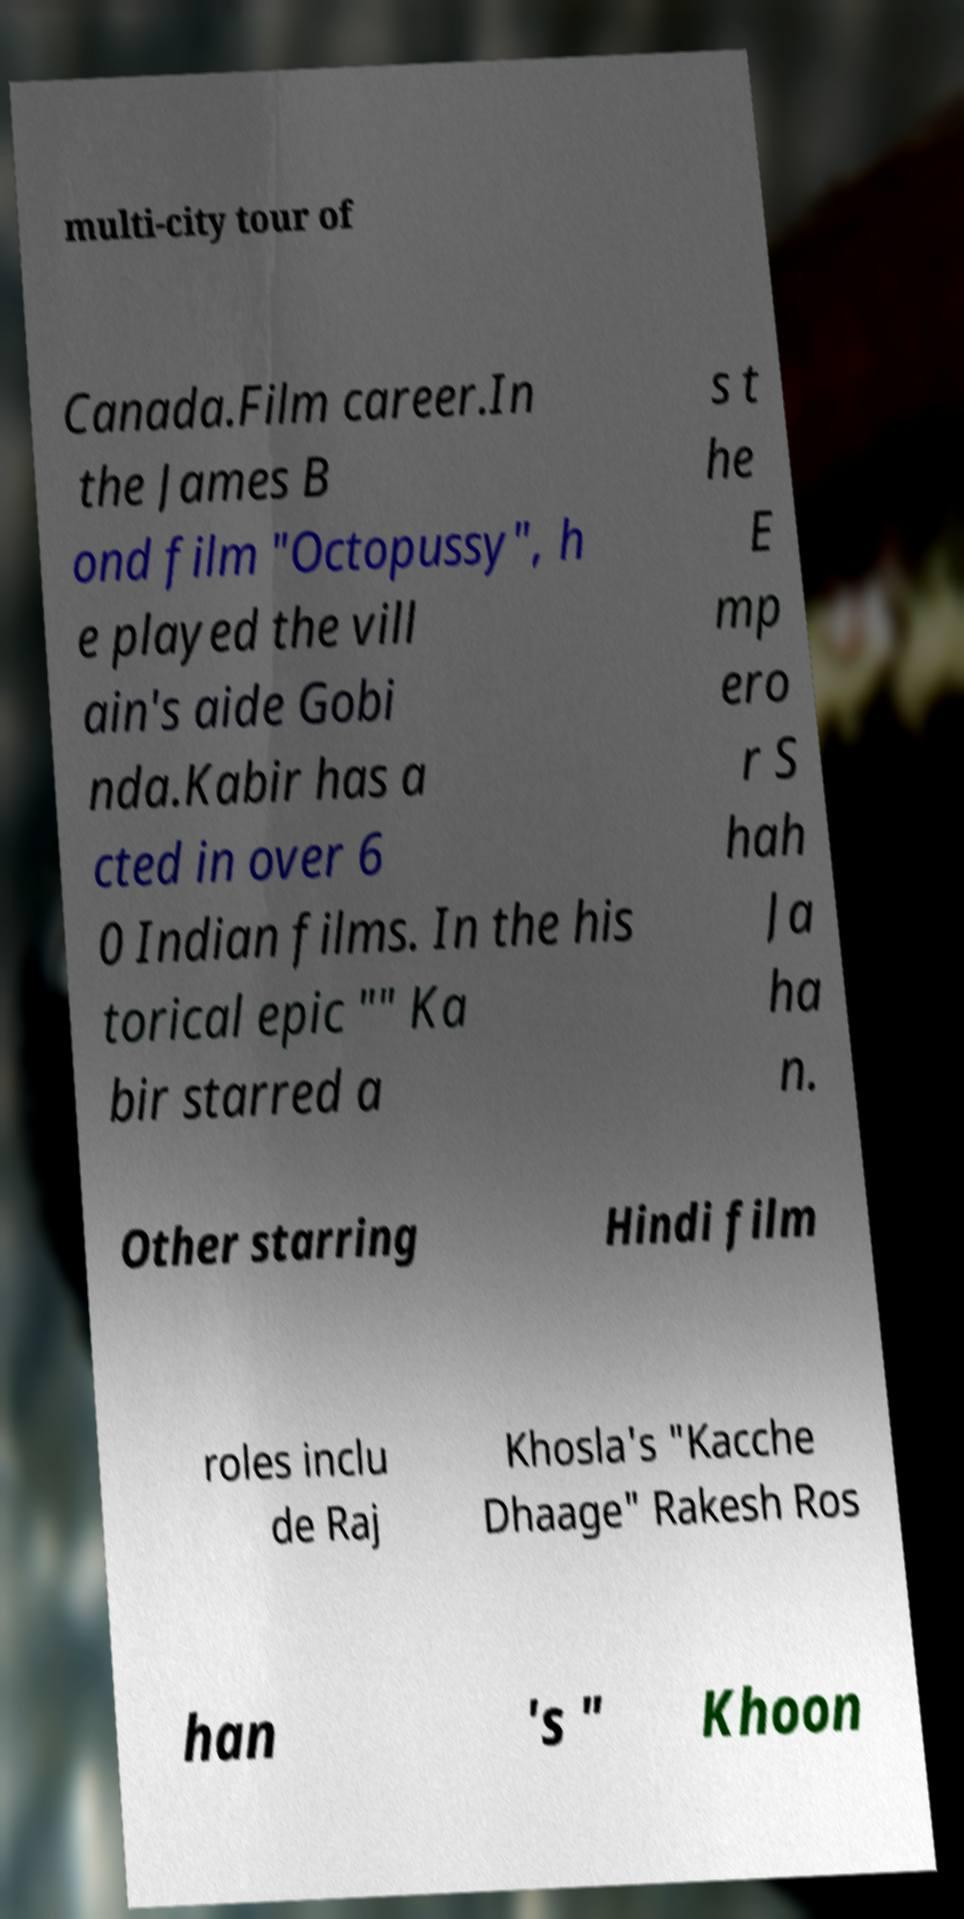I need the written content from this picture converted into text. Can you do that? multi-city tour of Canada.Film career.In the James B ond film "Octopussy", h e played the vill ain's aide Gobi nda.Kabir has a cted in over 6 0 Indian films. In the his torical epic "" Ka bir starred a s t he E mp ero r S hah Ja ha n. Other starring Hindi film roles inclu de Raj Khosla's "Kacche Dhaage" Rakesh Ros han 's " Khoon 